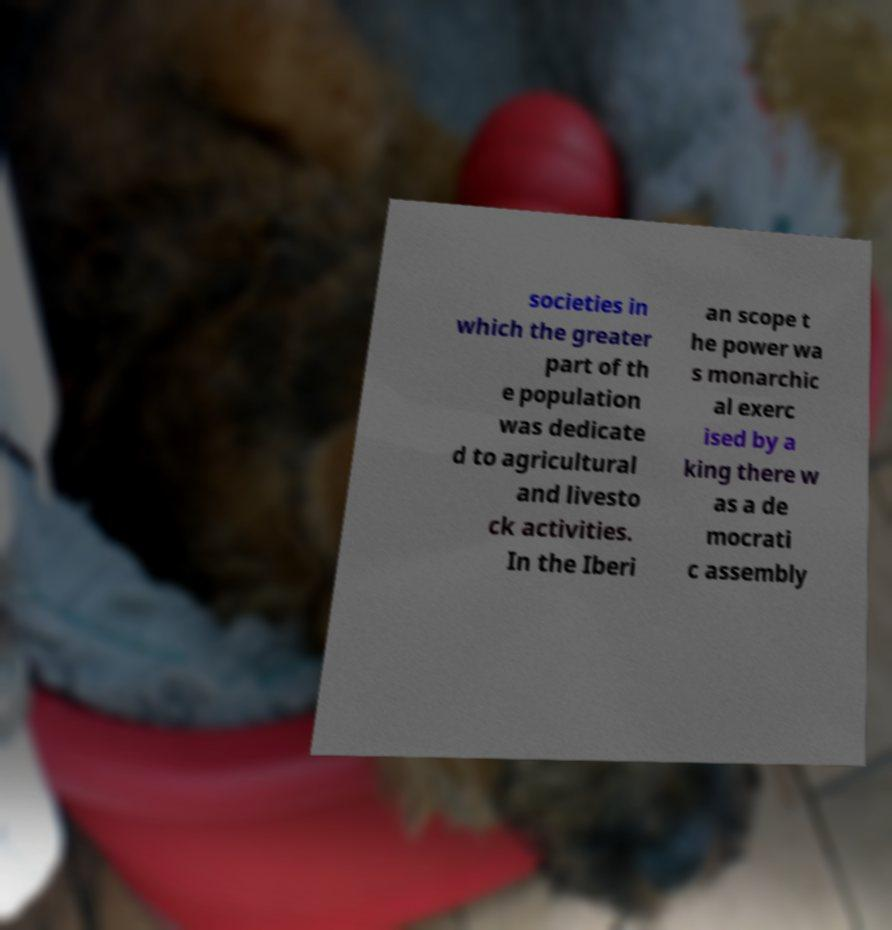I need the written content from this picture converted into text. Can you do that? societies in which the greater part of th e population was dedicate d to agricultural and livesto ck activities. In the Iberi an scope t he power wa s monarchic al exerc ised by a king there w as a de mocrati c assembly 